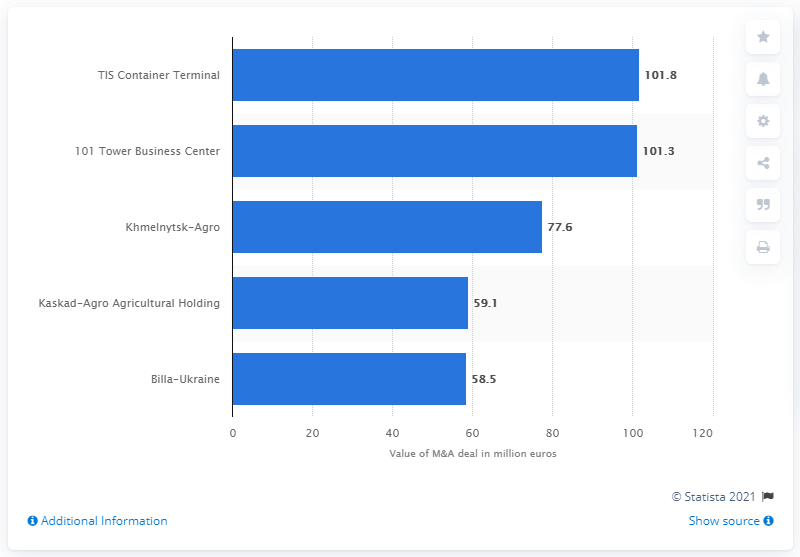Which company had the highest merger and acquisition value in 2021 as shown in the graph? The company with the highest merger and acquisition value in 2021 as depicted in the graph is TIS Container Terminal, with an M&A value of 101.8 million euros. 